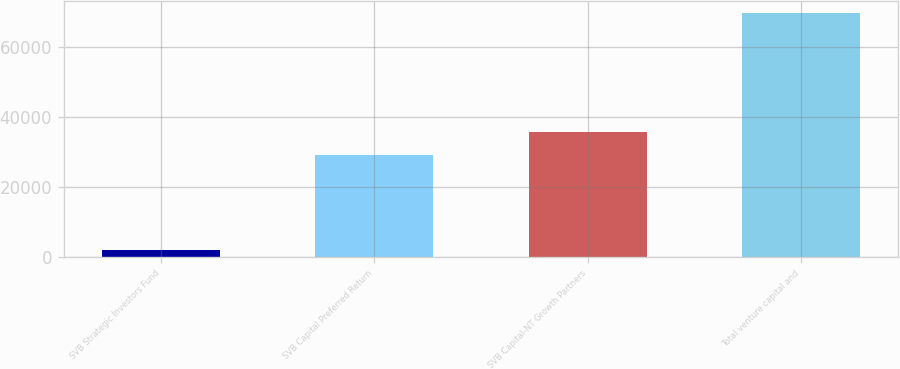<chart> <loc_0><loc_0><loc_500><loc_500><bar_chart><fcel>SVB Strategic Investors Fund<fcel>SVB Capital Preferred Return<fcel>SVB Capital-NT Growth Partners<fcel>Total venture capital and<nl><fcel>2032<fcel>29089.6<fcel>35854<fcel>69676<nl></chart> 